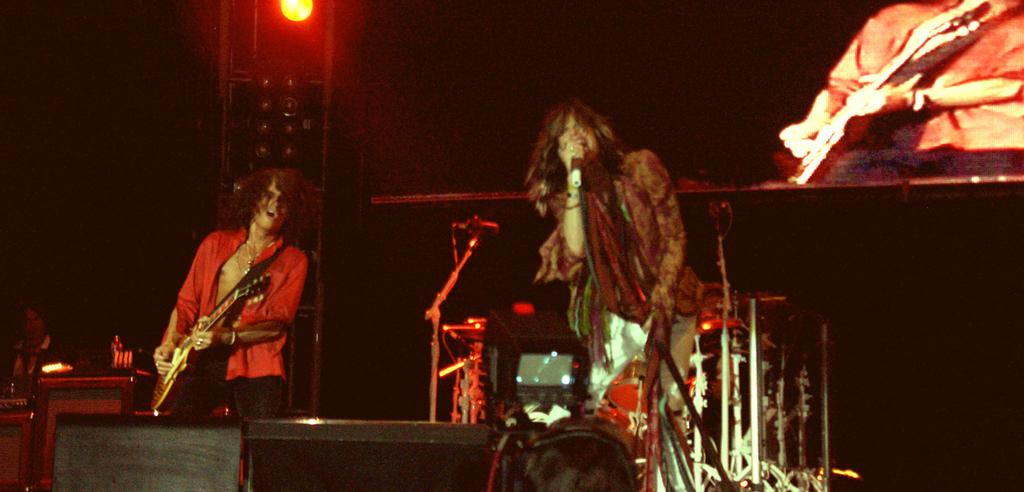What is the person wearing in the image? There is a person wearing a red dress in the image. What is the person in the red dress doing? The person in the red dress is playing a guitar. Can you describe the other person in the image? There is a person wearing brown clothing in the image. What is the person in brown doing? The person in brown is singing. What object is the person in brown standing near? The person in brown is standing in front of a microphone. Can you tell me how many quinces are on the stage in the image? There are no quinces present in the image; it features two people, one playing a guitar and the other singing. What type of toad can be seen interacting with the person in brown? There is no toad present in the image; it only features the two people and a microphone. 